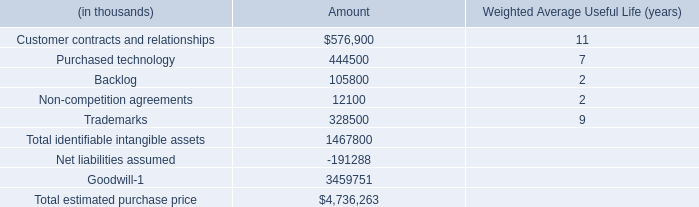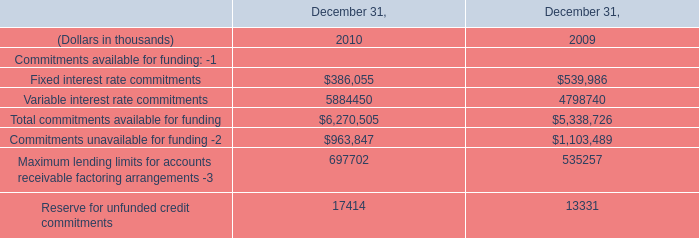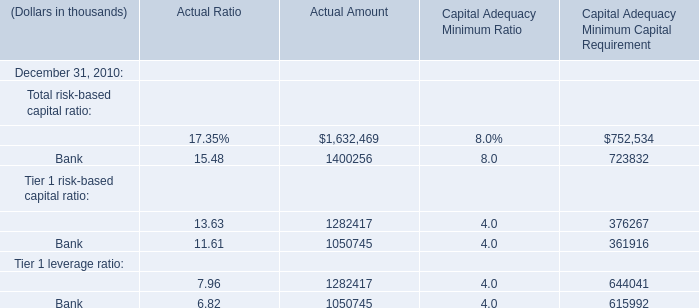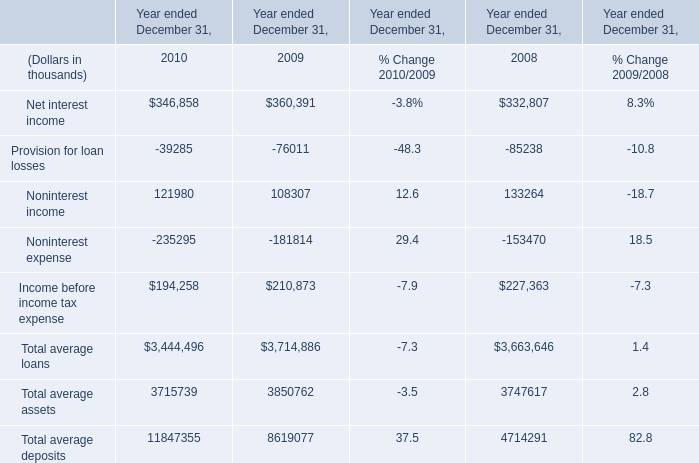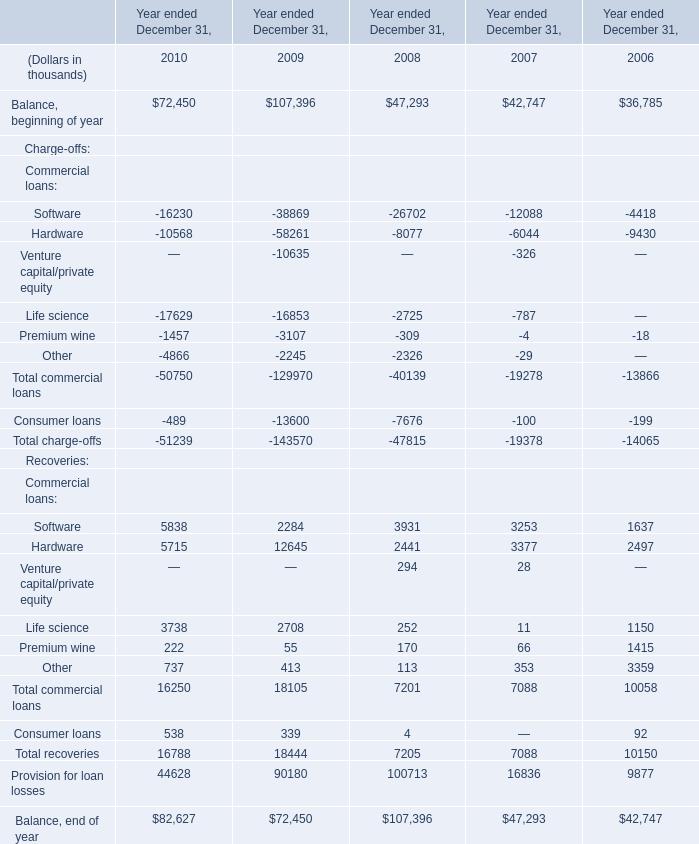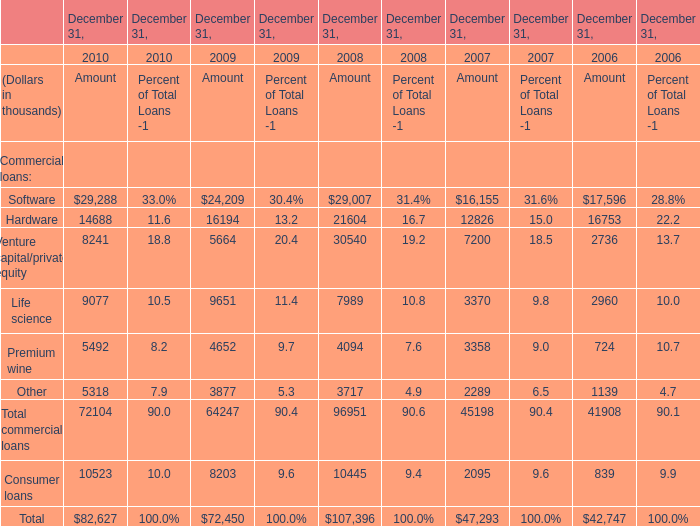What will Balance, beginning of year be like in 2011 if it develops with the same increasing rate as current? (in thousand) 
Computations: (72450 * (1 + ((72450 - 107396) / 107396)))
Answer: 48875.21416. 